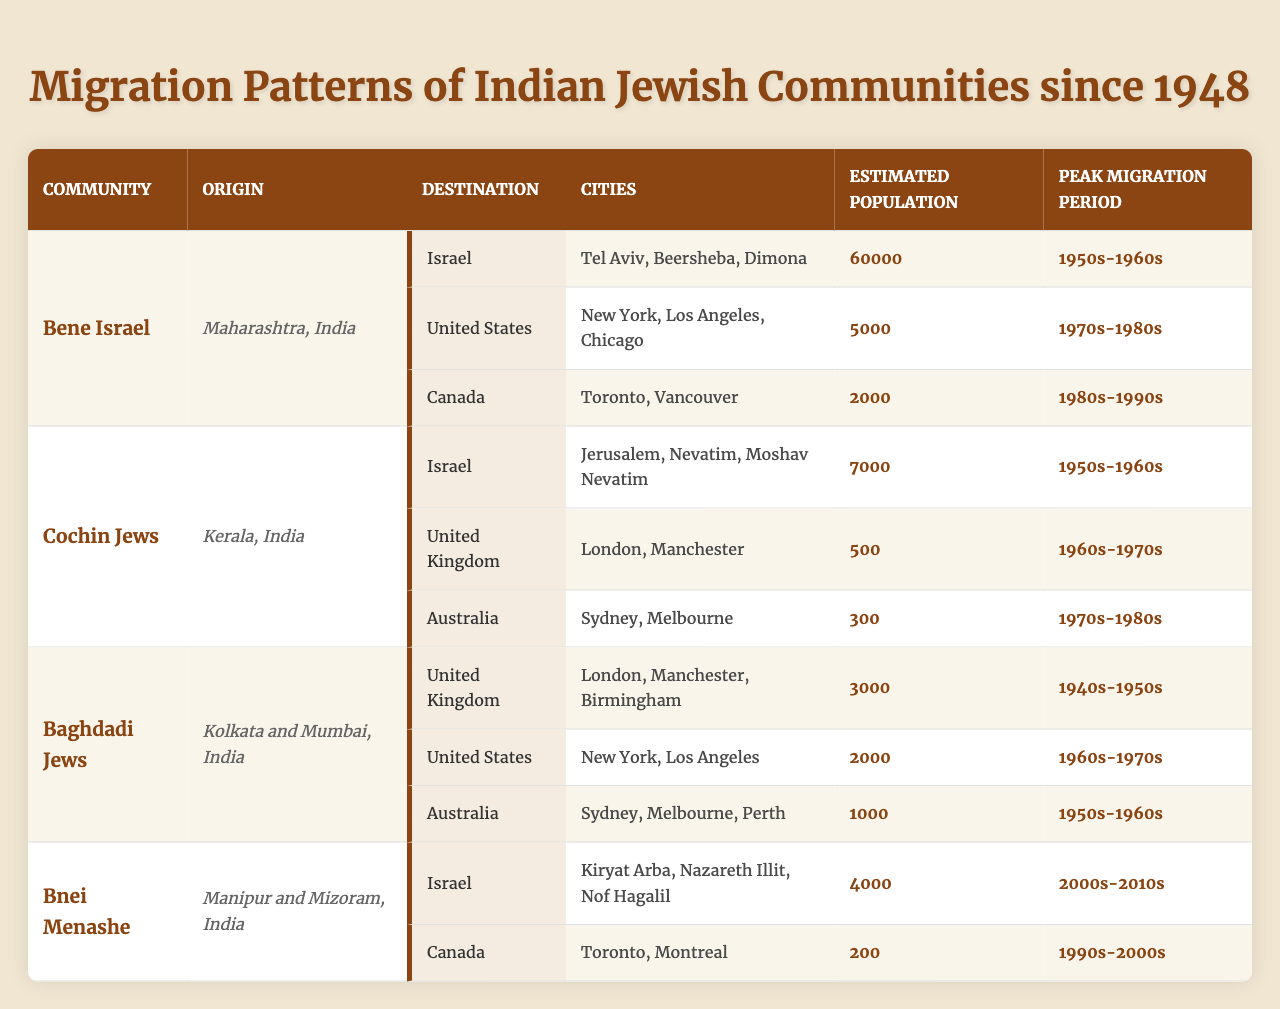What is the estimated population of the Bene Israel community in Israel? The table shows that the Bene Israel community has an estimated population of 60,000 in Israel.
Answer: 60,000 Which country had the peak migration period for the Cochin Jews? The peak migration period for the Cochin Jews was the 1950s-1960s, specifically to Israel.
Answer: Israel How many cities are listed for the Baghdadi Jews in Australia? The table shows that there are three cities listed for the Baghdadi Jews in Australia: Sydney, Melbourne, and Perth.
Answer: 3 What is the total estimated population for the Bnei Menashe community across its destinations? The Bnei Menashe community has an estimated population of 4,200, combining 4,000 in Israel and 200 in Canada. The total is 4,000 + 200 = 4,200.
Answer: 4,200 Did the Cochin Jews migrate to the United States? The table indicates that the Cochin Jews did not migrate to the United States, as its listed destinations do not include that country.
Answer: No What was the peak migration period for Baghdadi Jews migrating to the United States? The peak migration period for Baghdadi Jews migrating to the United States was during the 1960s-1970s according to the table.
Answer: 1960s-1970s Which community has the lowest estimated population in Canada, according to the table? The Bnei Menashe community has the lowest estimated population in Canada at 200, compared to the Bene Israel community with 2,000.
Answer: Bnei Menashe Compare the peak migration periods for Bene Israel and Baghdadi Jews to the United States. What can you conclude? The Bene Israel community's peak migration to the United States occurred in the 1970s-1980s, while the Baghdadi Jews migrated during the 1960s-1970s. Hence, there's an overlap, but the peak migration for Baghdadi Jews occurred slightly earlier.
Answer: Overlap in periods; Baghdadi earlier What is the total number of cities listed for the Bene Israel community in its destinations? There are seven cities listed for the Bene Israel community: Tel Aviv, Beersheba, Dimona in Israel; New York, Los Angeles, Chicago in the United States; and Toronto, Vancouver in Canada. The total is 7.
Answer: 7 Which country has the highest estimated population of Indian Jews among all communities listed in the table? Israel has the highest estimated population among Indian Jews with the Bene Israel community alone contributing 60,000.
Answer: Israel 